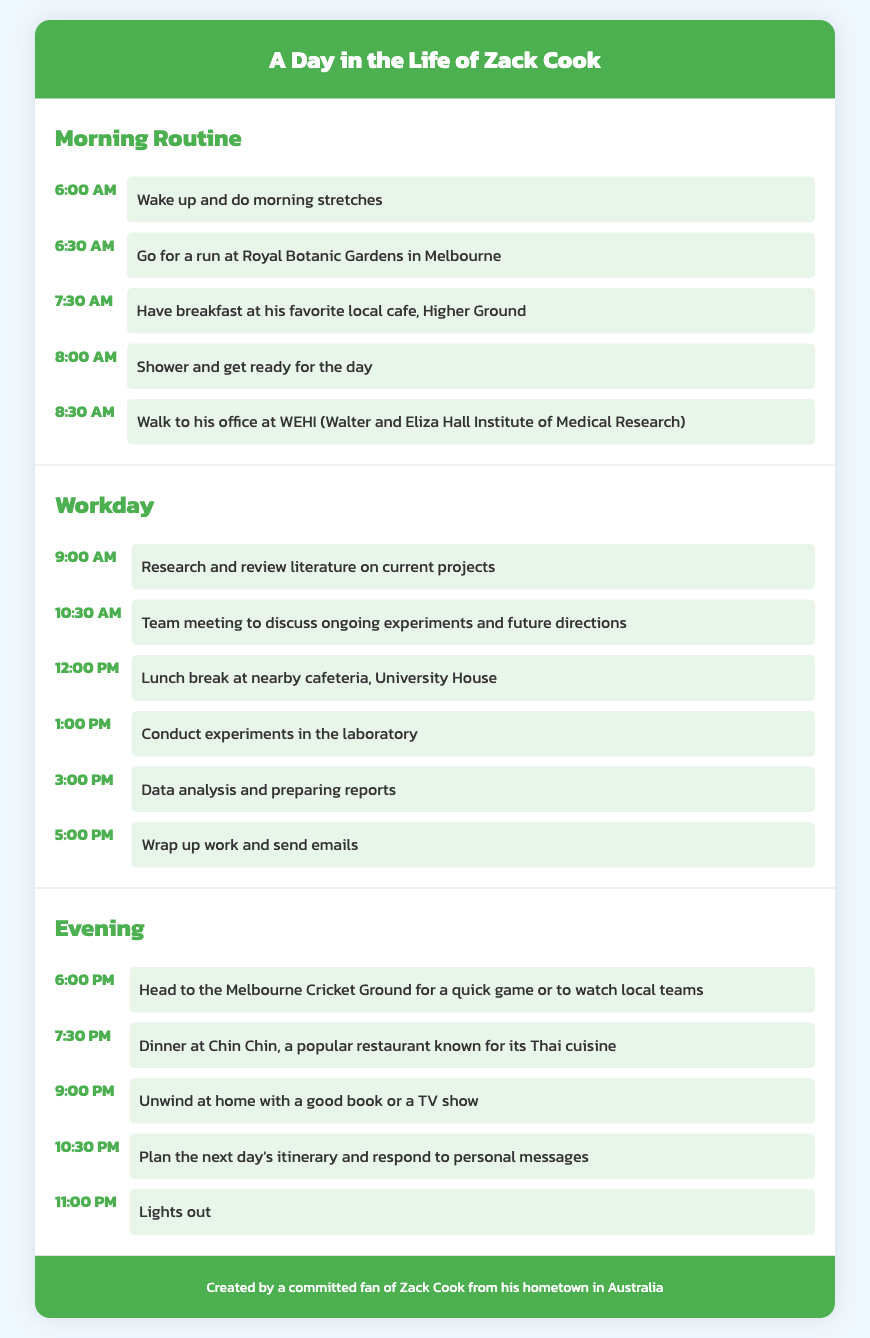what time does Zack wake up? The document states that Zack wakes up at 6:00 AM.
Answer: 6:00 AM where does Zack go for a run? It mentions that Zack goes for a run at Royal Botanic Gardens in Melbourne.
Answer: Royal Botanic Gardens in Melbourne what is the name of the restaurant where Zack has dinner? The itinerary lists Chin Chin as the restaurant where Zack has dinner.
Answer: Chin Chin how long is Zack's lunch break? Based on the itinerary, Zack has a lunch break from 12:00 PM to 1:00 PM, which is one hour.
Answer: one hour what activity does Zack do at 3:00 PM? At 3:00 PM, Zack is engaged in data analysis and preparing reports.
Answer: Data analysis and preparing reports how many activities are listed in the morning routine section? The morning routine section includes five distinct activities listed.
Answer: five what time does Zack plan the next day's itinerary? According to the document, Zack plans his next day's itinerary at 10:30 PM.
Answer: 10:30 PM what does Zack do at the Melbourne Cricket Ground? The document states that Zack heads to the Melbourne Cricket Ground for a quick game or to watch local teams.
Answer: quick game or to watch local teams 